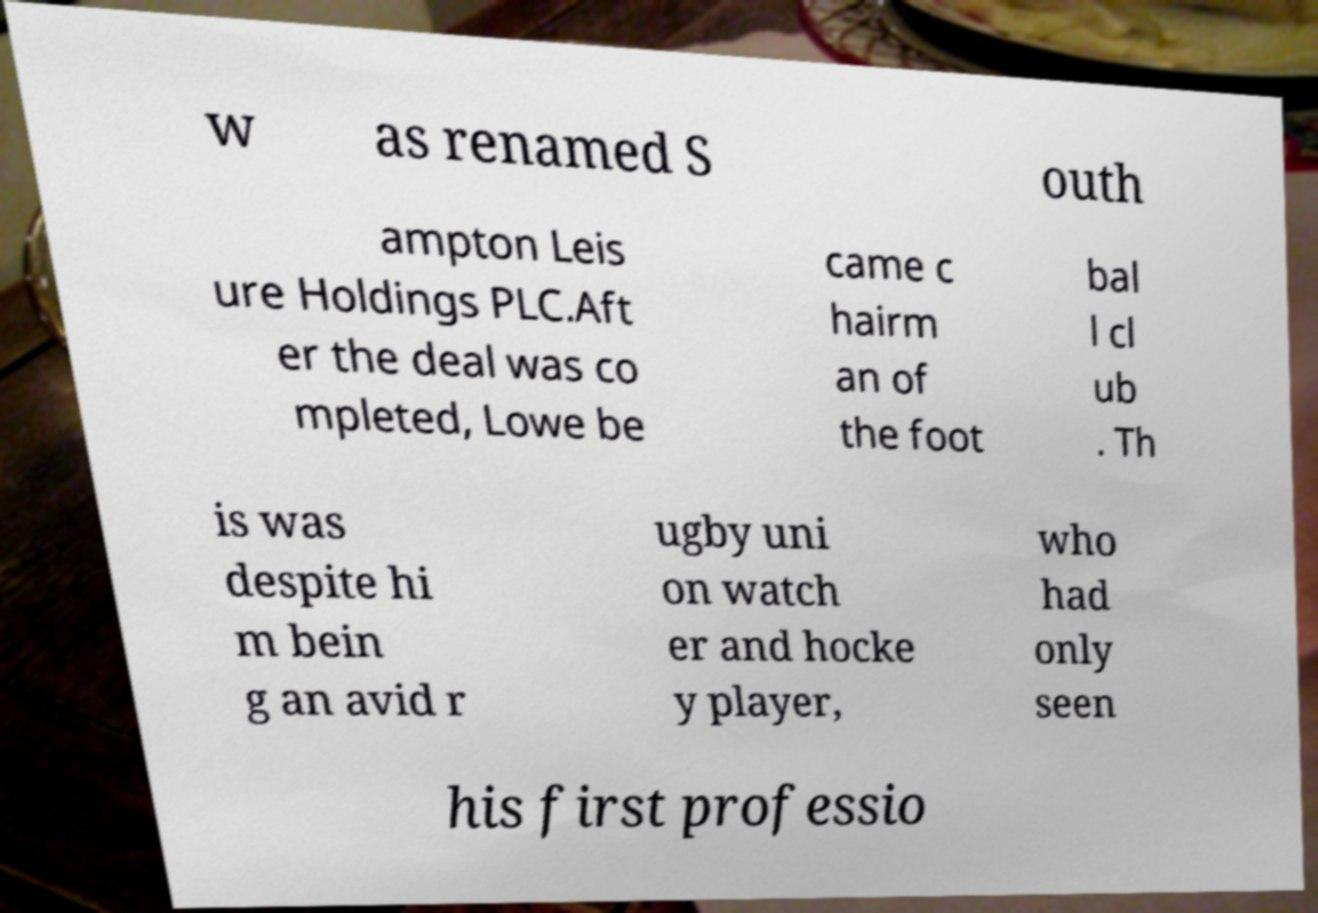Can you accurately transcribe the text from the provided image for me? w as renamed S outh ampton Leis ure Holdings PLC.Aft er the deal was co mpleted, Lowe be came c hairm an of the foot bal l cl ub . Th is was despite hi m bein g an avid r ugby uni on watch er and hocke y player, who had only seen his first professio 